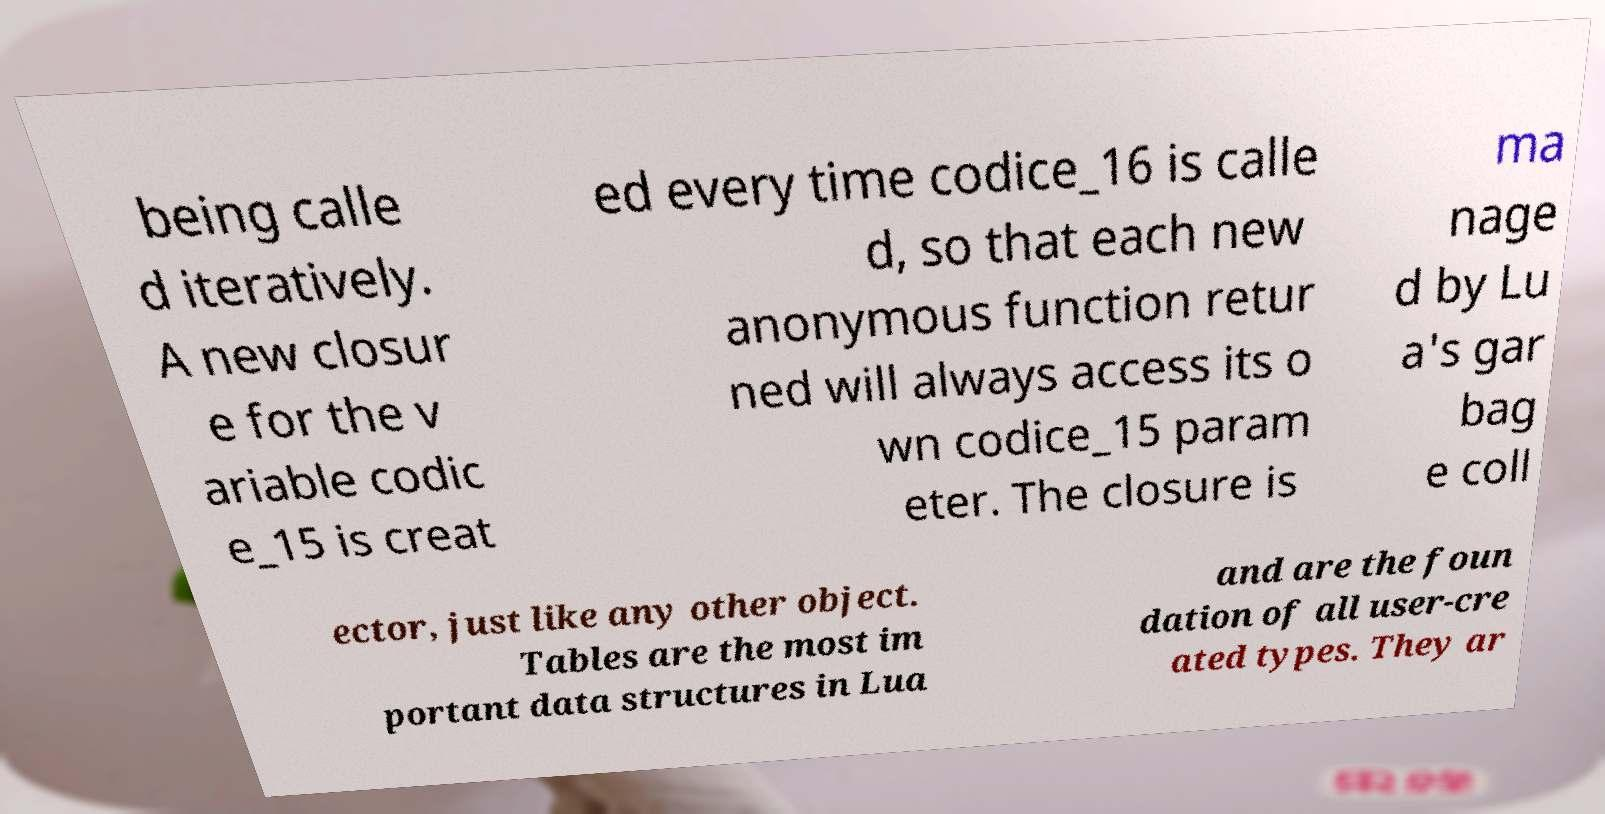Can you read and provide the text displayed in the image?This photo seems to have some interesting text. Can you extract and type it out for me? being calle d iteratively. A new closur e for the v ariable codic e_15 is creat ed every time codice_16 is calle d, so that each new anonymous function retur ned will always access its o wn codice_15 param eter. The closure is ma nage d by Lu a's gar bag e coll ector, just like any other object. Tables are the most im portant data structures in Lua and are the foun dation of all user-cre ated types. They ar 